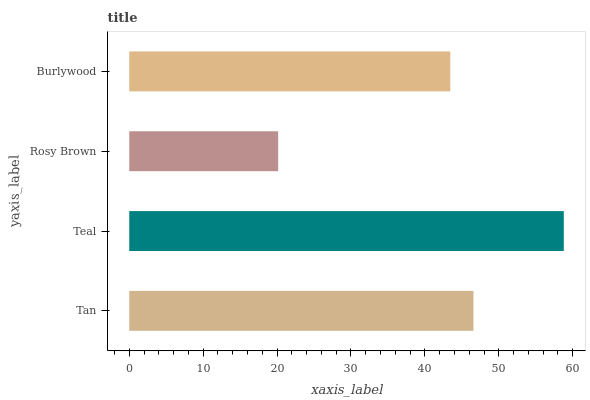Is Rosy Brown the minimum?
Answer yes or no. Yes. Is Teal the maximum?
Answer yes or no. Yes. Is Teal the minimum?
Answer yes or no. No. Is Rosy Brown the maximum?
Answer yes or no. No. Is Teal greater than Rosy Brown?
Answer yes or no. Yes. Is Rosy Brown less than Teal?
Answer yes or no. Yes. Is Rosy Brown greater than Teal?
Answer yes or no. No. Is Teal less than Rosy Brown?
Answer yes or no. No. Is Tan the high median?
Answer yes or no. Yes. Is Burlywood the low median?
Answer yes or no. Yes. Is Rosy Brown the high median?
Answer yes or no. No. Is Rosy Brown the low median?
Answer yes or no. No. 